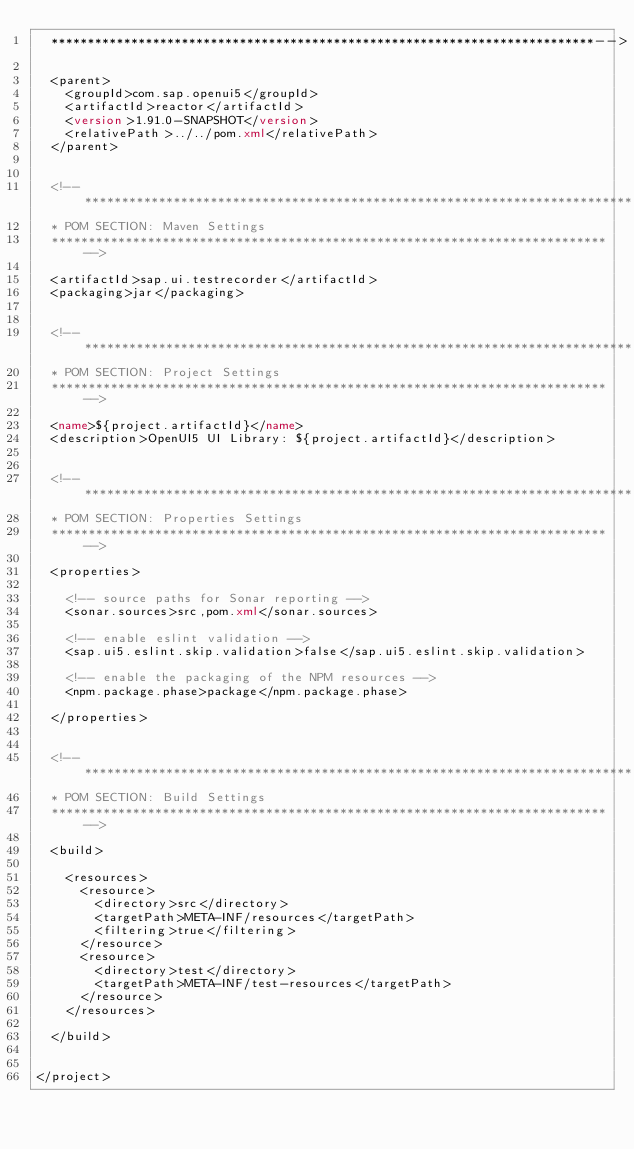Convert code to text. <code><loc_0><loc_0><loc_500><loc_500><_XML_>	***************************************************************************-->

	<parent>
		<groupId>com.sap.openui5</groupId>
		<artifactId>reactor</artifactId>
		<version>1.91.0-SNAPSHOT</version>
		<relativePath>../../pom.xml</relativePath>
	</parent>


	<!--**************************************************************************
	* POM SECTION: Maven Settings
	***************************************************************************-->

	<artifactId>sap.ui.testrecorder</artifactId>
	<packaging>jar</packaging>


	<!--**************************************************************************
	* POM SECTION: Project Settings
	***************************************************************************-->

	<name>${project.artifactId}</name>
	<description>OpenUI5 UI Library: ${project.artifactId}</description>


	<!--**************************************************************************
	* POM SECTION: Properties Settings
	***************************************************************************-->

	<properties>

		<!-- source paths for Sonar reporting -->
		<sonar.sources>src,pom.xml</sonar.sources>

		<!-- enable eslint validation -->
		<sap.ui5.eslint.skip.validation>false</sap.ui5.eslint.skip.validation>

		<!-- enable the packaging of the NPM resources -->
		<npm.package.phase>package</npm.package.phase>

	</properties>


	<!--**************************************************************************
	* POM SECTION: Build Settings
	***************************************************************************-->

	<build>

		<resources>
			<resource>
				<directory>src</directory>
				<targetPath>META-INF/resources</targetPath>
				<filtering>true</filtering>
			</resource>
			<resource>
				<directory>test</directory>
				<targetPath>META-INF/test-resources</targetPath>
			</resource>
		</resources>

	</build>


</project>
</code> 